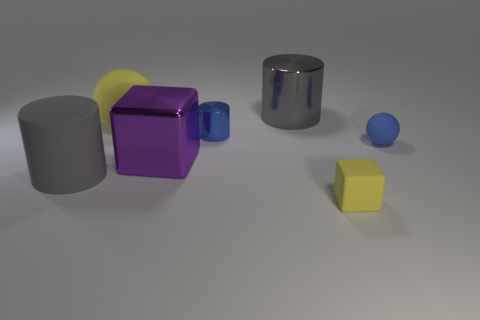What materials do the objects in the image appear to be made from? The objects in the image seem to have different materials. The gray cylinder and the chrome cylinder appear to be metallic. The purple cube looks like it has a metallic paint finish, and the yellow and blue objects have a matte finish that might suggest they're made from rubber or plastic. 